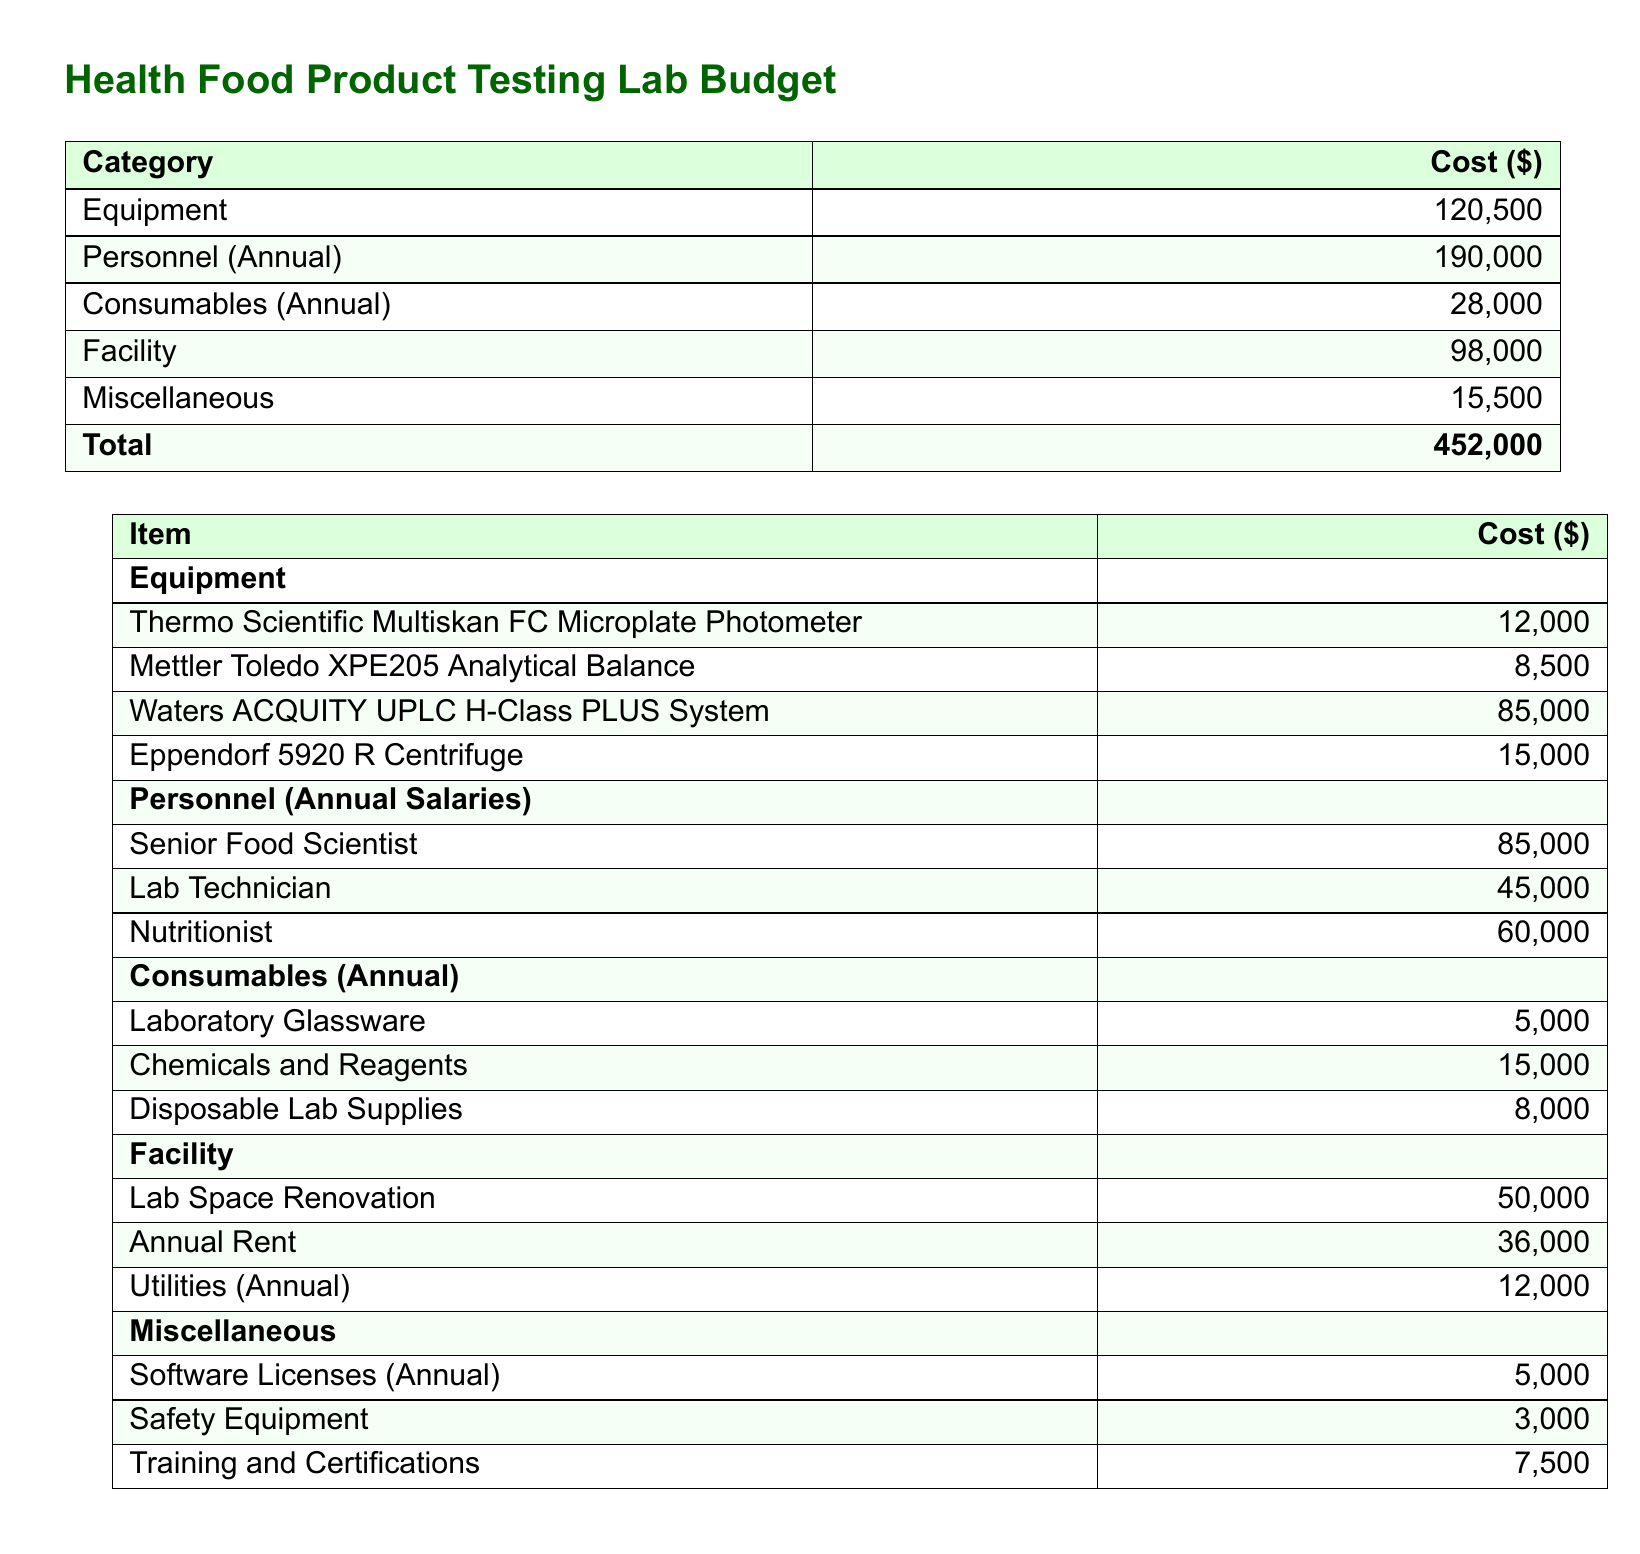What is the total projected cost for setting up the health food product testing lab? The total projected cost is presented in the budget summary at the end of the equipment and personnel sections.
Answer: 452,000 How much will the Waters ACQUITY UPLC H-Class PLUS System cost? The cost of this specific piece of equipment is listed in the detailed equipment section of the document.
Answer: 85,000 What is the annual salary of the Senior Food Scientist? The document specifies the annual salary for this role under the personnel section.
Answer: 85,000 What are the annual consumables costs? The total for consumables is provided in the budget, which includes laboratory glassware, chemicals and reagents, and disposable lab supplies.
Answer: 28,000 How much is allocated for safety equipment under miscellaneous expenses? The cost for safety equipment is detailed in the miscellaneous section of the budget.
Answer: 3,000 What is the cost of lab space renovation? The budget specifies the cost for renovation in the facility section.
Answer: 50,000 What is the annual cost for utilities? The budget explicitly lists the annual utility costs in the facility section.
Answer: 12,000 How much does it cost to train and certify personnel annually? The training and certifications expense is outlined in the miscellaneous section of the budget.
Answer: 7,500 What piece of equipment costs the most according to the document? The equipment with the highest cost is indicated in the detailed equipment section.
Answer: Waters ACQUITY UPLC H-Class PLUS System 